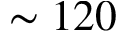<formula> <loc_0><loc_0><loc_500><loc_500>\sim 1 2 0</formula> 